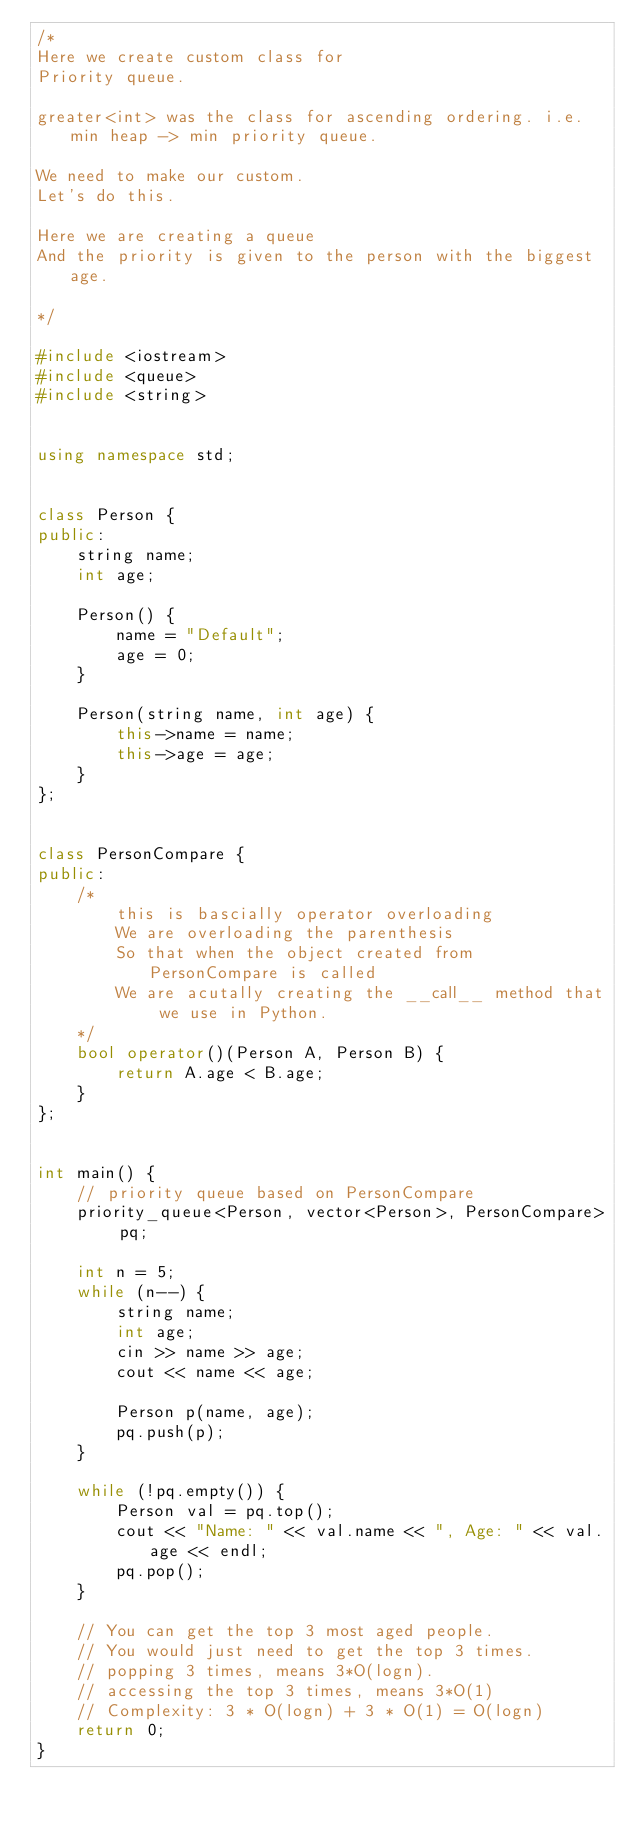Convert code to text. <code><loc_0><loc_0><loc_500><loc_500><_C++_>/*
Here we create custom class for
Priority queue.

greater<int> was the class for ascending ordering. i.e. min heap -> min priority queue.

We need to make our custom.
Let's do this.

Here we are creating a queue
And the priority is given to the person with the biggest age.

*/

#include <iostream>
#include <queue>
#include <string>


using namespace std;


class Person {
public:
    string name;
    int age;

    Person() {
        name = "Default";
        age = 0;
    }

    Person(string name, int age) {
        this->name = name;
        this->age = age;
    }
};


class PersonCompare {
public:
    /*
        this is bascially operator overloading
        We are overloading the parenthesis
        So that when the object created from PersonCompare is called
        We are acutally creating the __call__ method that we use in Python.
    */
    bool operator()(Person A, Person B) {
        return A.age < B.age;
    }
};


int main() {
    // priority queue based on PersonCompare
    priority_queue<Person, vector<Person>, PersonCompare> pq;

    int n = 5;
    while (n--) {
        string name;
        int age;
        cin >> name >> age;
        cout << name << age;

        Person p(name, age);
        pq.push(p);
    }

    while (!pq.empty()) {
        Person val = pq.top();
        cout << "Name: " << val.name << ", Age: " << val.age << endl;
        pq.pop();
    }

    // You can get the top 3 most aged people.
    // You would just need to get the top 3 times.
    // popping 3 times, means 3*O(logn).
    // accessing the top 3 times, means 3*O(1)
    // Complexity: 3 * O(logn) + 3 * O(1) = O(logn)
    return 0;
}
</code> 